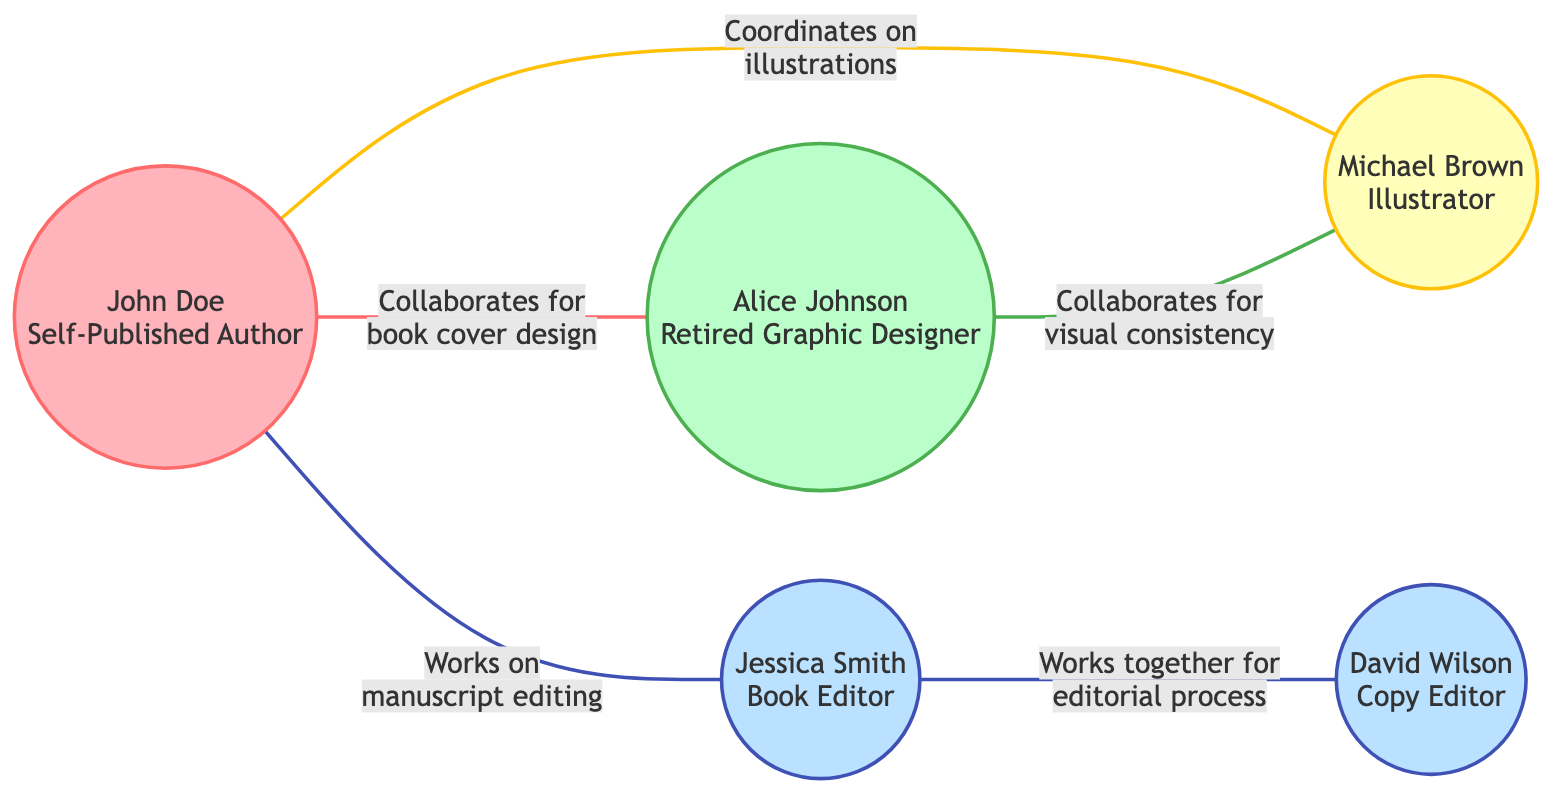What is the name of the self-published author in the diagram? The diagram shows a node labeled "Self-Published Author" with the name "John Doe."
Answer: John Doe How many individuals are represented in the diagram? By counting the unique nodes in the diagram, we find there are five individuals: the self-published author, retired graphic designer, two editors, and an illustrator.
Answer: 5 What role does Alice Johnson have in the collaboration network? The node labeled "Retired Graphic Designer" is linked to the name "Alice Johnson," indicating her role in the diagram.
Answer: Graphic Designer Which node is connected to both the self-published author and the illustrator? To find this, we look at the edges: "John Doe" (self-published author) has a direct edge to "Michael Brown" (illustrator), making that connection clear.
Answer: Michael Brown Which edge connects the two editors in the diagram? The link between "Jessica Smith" (Book Editor) and "David Wilson" (Copy Editor) shows their collaborative relationship, indicating their connection.
Answer: Works together for editorial process How many collaborative relationships involve the self-published author? There are three edges originating from "John Doe" that show the relationships with the designer, editor, and illustrator, confirming the count.
Answer: 3 What type of collaboration exists between the retired graphic designer and the illustrator? The link labeled "Collaborates for visual consistency" connects the retired graphic designer and the illustrator, indicating their partnership for the design purpose.
Answer: Collaborates for visual consistency Which role has the most connections in the diagram? By examining the edges and which nodes they connect, it's clear the self-published author has three edges connected to him, indicating he has the most collaborative ties.
Answer: Self-Published Author What is the purpose of the collaboration between the author and the editor? The edge labeled "Works on manuscript editing" between John Doe (author) and Jessica Smith (editor) specifies the nature of their collaboration.
Answer: Works on manuscript editing 